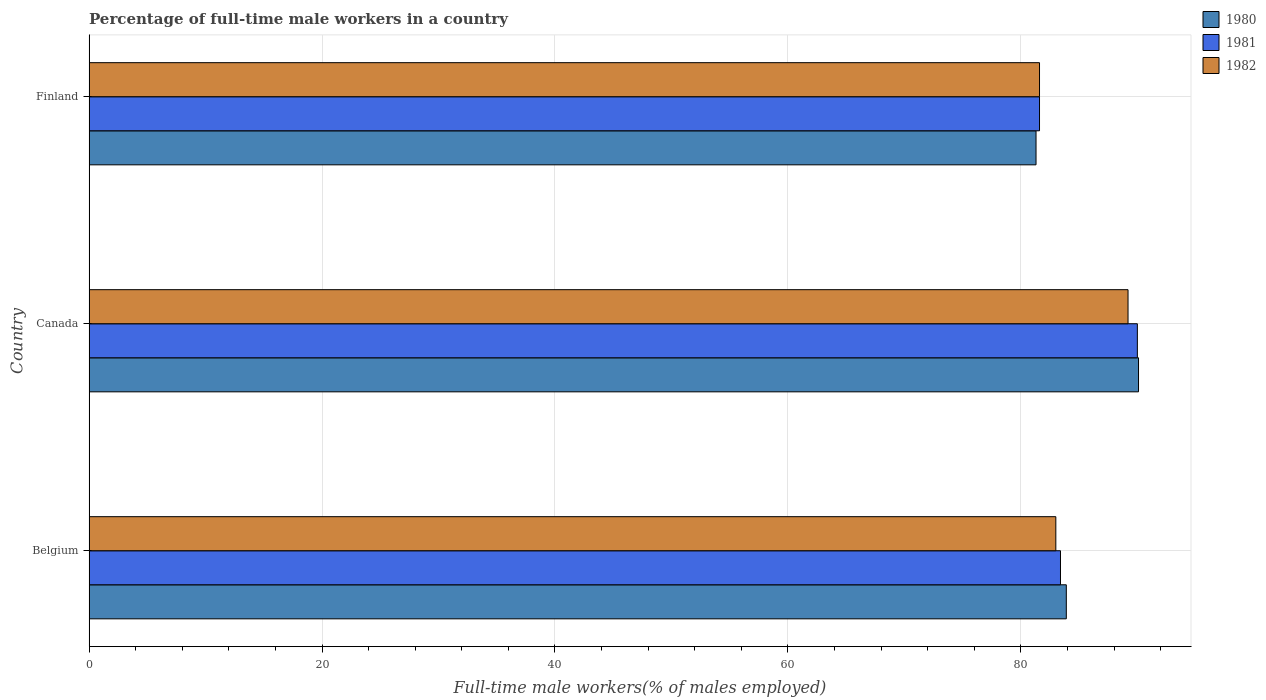How many different coloured bars are there?
Provide a succinct answer. 3. How many groups of bars are there?
Ensure brevity in your answer.  3. Are the number of bars per tick equal to the number of legend labels?
Your answer should be very brief. Yes. Are the number of bars on each tick of the Y-axis equal?
Provide a short and direct response. Yes. What is the label of the 2nd group of bars from the top?
Keep it short and to the point. Canada. What is the percentage of full-time male workers in 1980 in Finland?
Your response must be concise. 81.3. Across all countries, what is the minimum percentage of full-time male workers in 1982?
Ensure brevity in your answer.  81.6. In which country was the percentage of full-time male workers in 1981 maximum?
Ensure brevity in your answer.  Canada. What is the total percentage of full-time male workers in 1982 in the graph?
Make the answer very short. 253.8. What is the difference between the percentage of full-time male workers in 1982 in Belgium and that in Canada?
Provide a short and direct response. -6.2. What is the difference between the percentage of full-time male workers in 1981 in Canada and the percentage of full-time male workers in 1980 in Finland?
Your answer should be compact. 8.7. What is the average percentage of full-time male workers in 1980 per country?
Provide a short and direct response. 85.1. What is the difference between the percentage of full-time male workers in 1981 and percentage of full-time male workers in 1982 in Finland?
Give a very brief answer. 0. What is the ratio of the percentage of full-time male workers in 1981 in Belgium to that in Canada?
Provide a succinct answer. 0.93. What is the difference between the highest and the second highest percentage of full-time male workers in 1982?
Give a very brief answer. 6.2. What is the difference between the highest and the lowest percentage of full-time male workers in 1981?
Offer a very short reply. 8.4. In how many countries, is the percentage of full-time male workers in 1982 greater than the average percentage of full-time male workers in 1982 taken over all countries?
Make the answer very short. 1. Is the sum of the percentage of full-time male workers in 1982 in Belgium and Canada greater than the maximum percentage of full-time male workers in 1980 across all countries?
Make the answer very short. Yes. What does the 1st bar from the top in Belgium represents?
Keep it short and to the point. 1982. How many countries are there in the graph?
Provide a short and direct response. 3. Are the values on the major ticks of X-axis written in scientific E-notation?
Give a very brief answer. No. Does the graph contain any zero values?
Ensure brevity in your answer.  No. Where does the legend appear in the graph?
Give a very brief answer. Top right. How are the legend labels stacked?
Your answer should be very brief. Vertical. What is the title of the graph?
Give a very brief answer. Percentage of full-time male workers in a country. What is the label or title of the X-axis?
Provide a succinct answer. Full-time male workers(% of males employed). What is the Full-time male workers(% of males employed) in 1980 in Belgium?
Offer a very short reply. 83.9. What is the Full-time male workers(% of males employed) of 1981 in Belgium?
Give a very brief answer. 83.4. What is the Full-time male workers(% of males employed) in 1980 in Canada?
Ensure brevity in your answer.  90.1. What is the Full-time male workers(% of males employed) in 1982 in Canada?
Your answer should be compact. 89.2. What is the Full-time male workers(% of males employed) of 1980 in Finland?
Your answer should be very brief. 81.3. What is the Full-time male workers(% of males employed) of 1981 in Finland?
Keep it short and to the point. 81.6. What is the Full-time male workers(% of males employed) of 1982 in Finland?
Offer a terse response. 81.6. Across all countries, what is the maximum Full-time male workers(% of males employed) of 1980?
Give a very brief answer. 90.1. Across all countries, what is the maximum Full-time male workers(% of males employed) in 1981?
Offer a very short reply. 90. Across all countries, what is the maximum Full-time male workers(% of males employed) in 1982?
Provide a short and direct response. 89.2. Across all countries, what is the minimum Full-time male workers(% of males employed) in 1980?
Provide a short and direct response. 81.3. Across all countries, what is the minimum Full-time male workers(% of males employed) of 1981?
Give a very brief answer. 81.6. Across all countries, what is the minimum Full-time male workers(% of males employed) of 1982?
Your response must be concise. 81.6. What is the total Full-time male workers(% of males employed) of 1980 in the graph?
Keep it short and to the point. 255.3. What is the total Full-time male workers(% of males employed) of 1981 in the graph?
Keep it short and to the point. 255. What is the total Full-time male workers(% of males employed) in 1982 in the graph?
Provide a succinct answer. 253.8. What is the difference between the Full-time male workers(% of males employed) in 1982 in Belgium and that in Canada?
Your answer should be compact. -6.2. What is the difference between the Full-time male workers(% of males employed) in 1980 in Belgium and that in Finland?
Offer a terse response. 2.6. What is the difference between the Full-time male workers(% of males employed) in 1981 in Belgium and that in Finland?
Your answer should be compact. 1.8. What is the difference between the Full-time male workers(% of males employed) in 1982 in Belgium and that in Finland?
Make the answer very short. 1.4. What is the difference between the Full-time male workers(% of males employed) of 1980 in Canada and that in Finland?
Offer a very short reply. 8.8. What is the difference between the Full-time male workers(% of males employed) of 1982 in Canada and that in Finland?
Give a very brief answer. 7.6. What is the difference between the Full-time male workers(% of males employed) of 1980 in Belgium and the Full-time male workers(% of males employed) of 1981 in Canada?
Provide a short and direct response. -6.1. What is the difference between the Full-time male workers(% of males employed) of 1980 in Belgium and the Full-time male workers(% of males employed) of 1981 in Finland?
Ensure brevity in your answer.  2.3. What is the difference between the Full-time male workers(% of males employed) in 1980 in Belgium and the Full-time male workers(% of males employed) in 1982 in Finland?
Give a very brief answer. 2.3. What is the difference between the Full-time male workers(% of males employed) of 1981 in Belgium and the Full-time male workers(% of males employed) of 1982 in Finland?
Provide a succinct answer. 1.8. What is the difference between the Full-time male workers(% of males employed) in 1980 in Canada and the Full-time male workers(% of males employed) in 1981 in Finland?
Keep it short and to the point. 8.5. What is the difference between the Full-time male workers(% of males employed) in 1980 in Canada and the Full-time male workers(% of males employed) in 1982 in Finland?
Ensure brevity in your answer.  8.5. What is the difference between the Full-time male workers(% of males employed) in 1981 in Canada and the Full-time male workers(% of males employed) in 1982 in Finland?
Give a very brief answer. 8.4. What is the average Full-time male workers(% of males employed) of 1980 per country?
Provide a short and direct response. 85.1. What is the average Full-time male workers(% of males employed) of 1981 per country?
Provide a succinct answer. 85. What is the average Full-time male workers(% of males employed) in 1982 per country?
Your answer should be very brief. 84.6. What is the difference between the Full-time male workers(% of males employed) in 1980 and Full-time male workers(% of males employed) in 1981 in Belgium?
Ensure brevity in your answer.  0.5. What is the difference between the Full-time male workers(% of males employed) in 1980 and Full-time male workers(% of males employed) in 1982 in Belgium?
Your response must be concise. 0.9. What is the difference between the Full-time male workers(% of males employed) in 1980 and Full-time male workers(% of males employed) in 1982 in Finland?
Your answer should be very brief. -0.3. What is the ratio of the Full-time male workers(% of males employed) of 1980 in Belgium to that in Canada?
Offer a terse response. 0.93. What is the ratio of the Full-time male workers(% of males employed) in 1981 in Belgium to that in Canada?
Provide a short and direct response. 0.93. What is the ratio of the Full-time male workers(% of males employed) of 1982 in Belgium to that in Canada?
Provide a short and direct response. 0.93. What is the ratio of the Full-time male workers(% of males employed) in 1980 in Belgium to that in Finland?
Your response must be concise. 1.03. What is the ratio of the Full-time male workers(% of males employed) in 1981 in Belgium to that in Finland?
Your answer should be very brief. 1.02. What is the ratio of the Full-time male workers(% of males employed) in 1982 in Belgium to that in Finland?
Make the answer very short. 1.02. What is the ratio of the Full-time male workers(% of males employed) of 1980 in Canada to that in Finland?
Offer a terse response. 1.11. What is the ratio of the Full-time male workers(% of males employed) of 1981 in Canada to that in Finland?
Keep it short and to the point. 1.1. What is the ratio of the Full-time male workers(% of males employed) in 1982 in Canada to that in Finland?
Provide a succinct answer. 1.09. What is the difference between the highest and the lowest Full-time male workers(% of males employed) in 1981?
Make the answer very short. 8.4. 